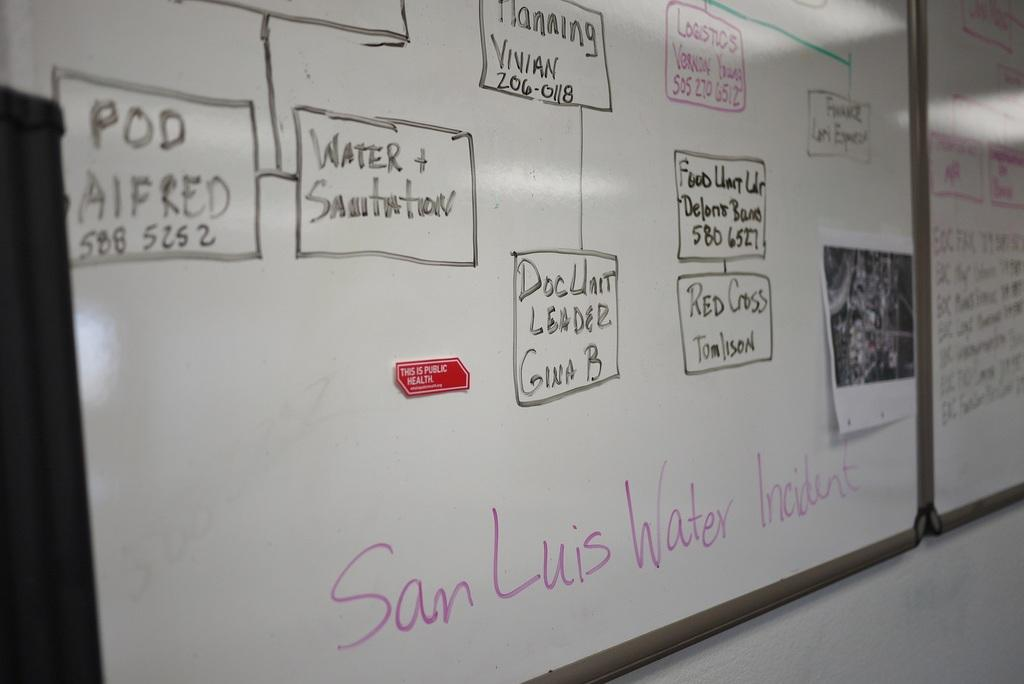<image>
Relay a brief, clear account of the picture shown. Water and Sanitation are topics written on a white board on the walls. 